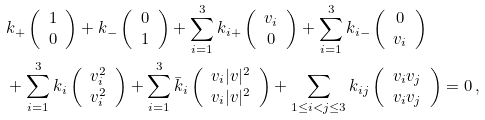Convert formula to latex. <formula><loc_0><loc_0><loc_500><loc_500>& k _ { + } \left ( \begin{array} { c } 1 \\ 0 \end{array} \right ) + k _ { - } \left ( \begin{array} { c } 0 \\ 1 \end{array} \right ) + \sum _ { i = 1 } ^ { 3 } k _ { i + } \left ( \begin{array} { c } v _ { i } \\ 0 \end{array} \right ) + \sum _ { i = 1 } ^ { 3 } k _ { i - } \left ( \begin{array} { c } 0 \\ v _ { i } \end{array} \right ) \\ & + \sum _ { i = 1 } ^ { 3 } k _ { i } \left ( \begin{array} { c } v _ { i } ^ { 2 } \\ v _ { i } ^ { 2 } \end{array} \right ) + \sum _ { i = 1 } ^ { 3 } \bar { k } _ { i } \left ( \begin{array} { c } v _ { i } | v | ^ { 2 } \\ v _ { i } | v | ^ { 2 } \end{array} \right ) + \sum _ { 1 \leq i < j \leq 3 } k _ { i j } \left ( \begin{array} { c } v _ { i } v _ { j } \\ v _ { i } v _ { j } \end{array} \right ) = 0 \, ,</formula> 